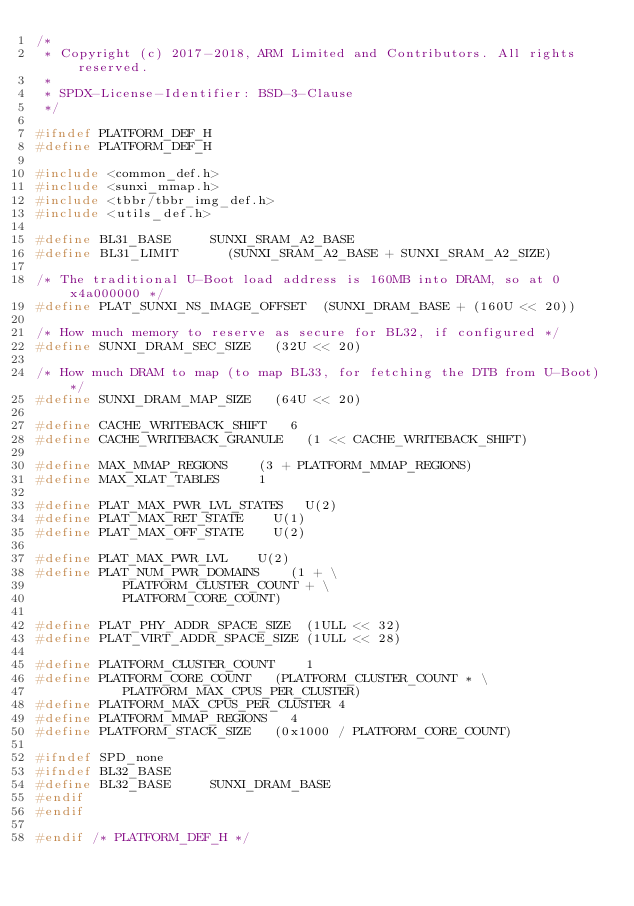Convert code to text. <code><loc_0><loc_0><loc_500><loc_500><_C_>/*
 * Copyright (c) 2017-2018, ARM Limited and Contributors. All rights reserved.
 *
 * SPDX-License-Identifier: BSD-3-Clause
 */

#ifndef PLATFORM_DEF_H
#define PLATFORM_DEF_H

#include <common_def.h>
#include <sunxi_mmap.h>
#include <tbbr/tbbr_img_def.h>
#include <utils_def.h>

#define BL31_BASE			SUNXI_SRAM_A2_BASE
#define BL31_LIMIT			(SUNXI_SRAM_A2_BASE + SUNXI_SRAM_A2_SIZE)

/* The traditional U-Boot load address is 160MB into DRAM, so at 0x4a000000 */
#define PLAT_SUNXI_NS_IMAGE_OFFSET	(SUNXI_DRAM_BASE + (160U << 20))

/* How much memory to reserve as secure for BL32, if configured */
#define SUNXI_DRAM_SEC_SIZE		(32U << 20)

/* How much DRAM to map (to map BL33, for fetching the DTB from U-Boot) */
#define SUNXI_DRAM_MAP_SIZE		(64U << 20)

#define CACHE_WRITEBACK_SHIFT		6
#define CACHE_WRITEBACK_GRANULE		(1 << CACHE_WRITEBACK_SHIFT)

#define MAX_MMAP_REGIONS		(3 + PLATFORM_MMAP_REGIONS)
#define MAX_XLAT_TABLES			1

#define PLAT_MAX_PWR_LVL_STATES		U(2)
#define PLAT_MAX_RET_STATE		U(1)
#define PLAT_MAX_OFF_STATE		U(2)

#define PLAT_MAX_PWR_LVL		U(2)
#define PLAT_NUM_PWR_DOMAINS		(1 + \
					 PLATFORM_CLUSTER_COUNT + \
					 PLATFORM_CORE_COUNT)

#define PLAT_PHY_ADDR_SPACE_SIZE	(1ULL << 32)
#define PLAT_VIRT_ADDR_SPACE_SIZE	(1ULL << 28)

#define PLATFORM_CLUSTER_COUNT		1
#define PLATFORM_CORE_COUNT		(PLATFORM_CLUSTER_COUNT * \
					 PLATFORM_MAX_CPUS_PER_CLUSTER)
#define PLATFORM_MAX_CPUS_PER_CLUSTER	4
#define PLATFORM_MMAP_REGIONS		4
#define PLATFORM_STACK_SIZE		(0x1000 / PLATFORM_CORE_COUNT)

#ifndef SPD_none
#ifndef BL32_BASE
#define BL32_BASE			SUNXI_DRAM_BASE
#endif
#endif

#endif /* PLATFORM_DEF_H */
</code> 